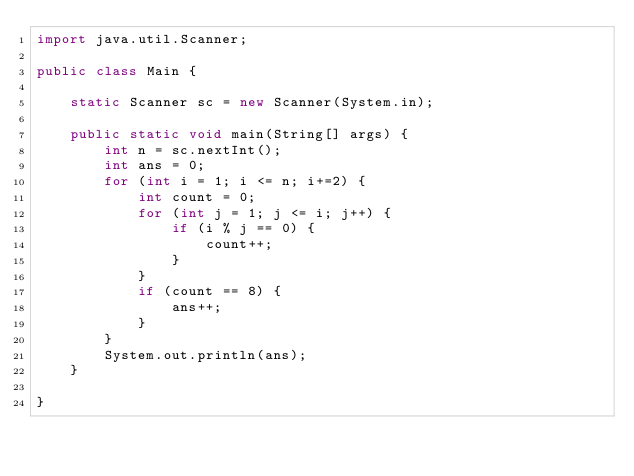<code> <loc_0><loc_0><loc_500><loc_500><_Java_>import java.util.Scanner;

public class Main {

    static Scanner sc = new Scanner(System.in);

    public static void main(String[] args) {
        int n = sc.nextInt();
        int ans = 0;
        for (int i = 1; i <= n; i+=2) {
            int count = 0;
            for (int j = 1; j <= i; j++) {
                if (i % j == 0) {
                    count++;
                }
            }
            if (count == 8) {
                ans++;
            }
        }
        System.out.println(ans);
    }

}
</code> 